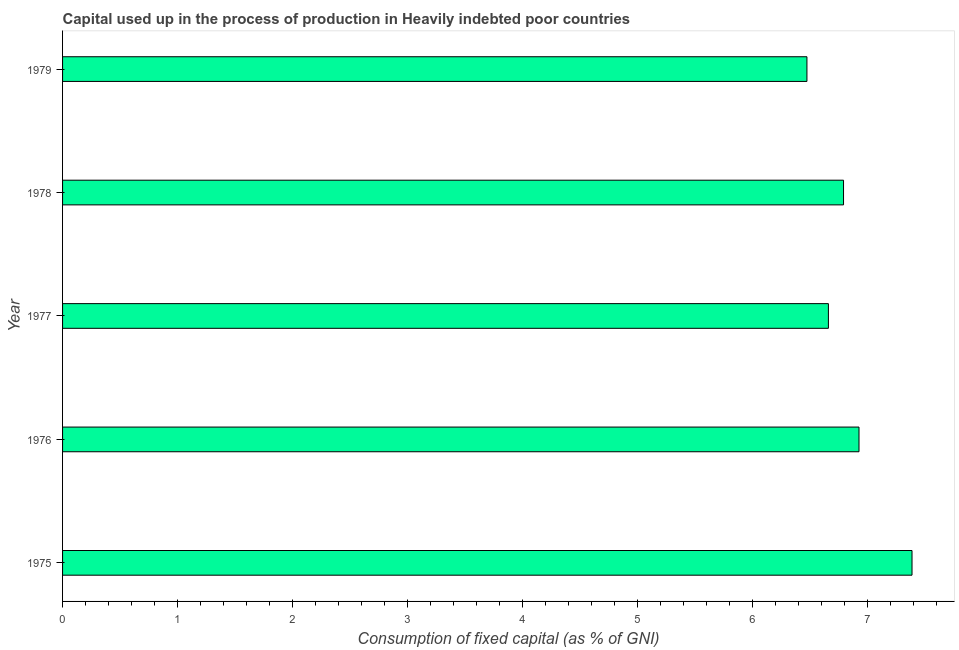Does the graph contain grids?
Offer a very short reply. No. What is the title of the graph?
Offer a very short reply. Capital used up in the process of production in Heavily indebted poor countries. What is the label or title of the X-axis?
Provide a succinct answer. Consumption of fixed capital (as % of GNI). What is the label or title of the Y-axis?
Offer a terse response. Year. What is the consumption of fixed capital in 1978?
Ensure brevity in your answer.  6.79. Across all years, what is the maximum consumption of fixed capital?
Provide a short and direct response. 7.39. Across all years, what is the minimum consumption of fixed capital?
Offer a very short reply. 6.47. In which year was the consumption of fixed capital maximum?
Your answer should be compact. 1975. In which year was the consumption of fixed capital minimum?
Make the answer very short. 1979. What is the sum of the consumption of fixed capital?
Make the answer very short. 34.24. What is the difference between the consumption of fixed capital in 1977 and 1978?
Ensure brevity in your answer.  -0.13. What is the average consumption of fixed capital per year?
Offer a terse response. 6.85. What is the median consumption of fixed capital?
Your response must be concise. 6.79. In how many years, is the consumption of fixed capital greater than 3.2 %?
Make the answer very short. 5. What is the ratio of the consumption of fixed capital in 1978 to that in 1979?
Provide a succinct answer. 1.05. Is the difference between the consumption of fixed capital in 1975 and 1978 greater than the difference between any two years?
Keep it short and to the point. No. What is the difference between the highest and the second highest consumption of fixed capital?
Your response must be concise. 0.46. What is the difference between the highest and the lowest consumption of fixed capital?
Offer a terse response. 0.91. In how many years, is the consumption of fixed capital greater than the average consumption of fixed capital taken over all years?
Your answer should be compact. 2. How many bars are there?
Provide a succinct answer. 5. Are the values on the major ticks of X-axis written in scientific E-notation?
Ensure brevity in your answer.  No. What is the Consumption of fixed capital (as % of GNI) in 1975?
Provide a short and direct response. 7.39. What is the Consumption of fixed capital (as % of GNI) in 1976?
Your answer should be very brief. 6.93. What is the Consumption of fixed capital (as % of GNI) of 1977?
Provide a succinct answer. 6.66. What is the Consumption of fixed capital (as % of GNI) in 1978?
Your response must be concise. 6.79. What is the Consumption of fixed capital (as % of GNI) in 1979?
Make the answer very short. 6.47. What is the difference between the Consumption of fixed capital (as % of GNI) in 1975 and 1976?
Give a very brief answer. 0.46. What is the difference between the Consumption of fixed capital (as % of GNI) in 1975 and 1977?
Ensure brevity in your answer.  0.73. What is the difference between the Consumption of fixed capital (as % of GNI) in 1975 and 1978?
Ensure brevity in your answer.  0.6. What is the difference between the Consumption of fixed capital (as % of GNI) in 1975 and 1979?
Your answer should be very brief. 0.91. What is the difference between the Consumption of fixed capital (as % of GNI) in 1976 and 1977?
Your answer should be very brief. 0.27. What is the difference between the Consumption of fixed capital (as % of GNI) in 1976 and 1978?
Your answer should be compact. 0.13. What is the difference between the Consumption of fixed capital (as % of GNI) in 1976 and 1979?
Your answer should be very brief. 0.45. What is the difference between the Consumption of fixed capital (as % of GNI) in 1977 and 1978?
Your response must be concise. -0.13. What is the difference between the Consumption of fixed capital (as % of GNI) in 1977 and 1979?
Offer a very short reply. 0.19. What is the difference between the Consumption of fixed capital (as % of GNI) in 1978 and 1979?
Keep it short and to the point. 0.32. What is the ratio of the Consumption of fixed capital (as % of GNI) in 1975 to that in 1976?
Your response must be concise. 1.07. What is the ratio of the Consumption of fixed capital (as % of GNI) in 1975 to that in 1977?
Provide a succinct answer. 1.11. What is the ratio of the Consumption of fixed capital (as % of GNI) in 1975 to that in 1978?
Offer a very short reply. 1.09. What is the ratio of the Consumption of fixed capital (as % of GNI) in 1975 to that in 1979?
Provide a short and direct response. 1.14. What is the ratio of the Consumption of fixed capital (as % of GNI) in 1976 to that in 1977?
Your response must be concise. 1.04. What is the ratio of the Consumption of fixed capital (as % of GNI) in 1976 to that in 1978?
Your response must be concise. 1.02. What is the ratio of the Consumption of fixed capital (as % of GNI) in 1976 to that in 1979?
Your response must be concise. 1.07. What is the ratio of the Consumption of fixed capital (as % of GNI) in 1977 to that in 1979?
Make the answer very short. 1.03. What is the ratio of the Consumption of fixed capital (as % of GNI) in 1978 to that in 1979?
Ensure brevity in your answer.  1.05. 